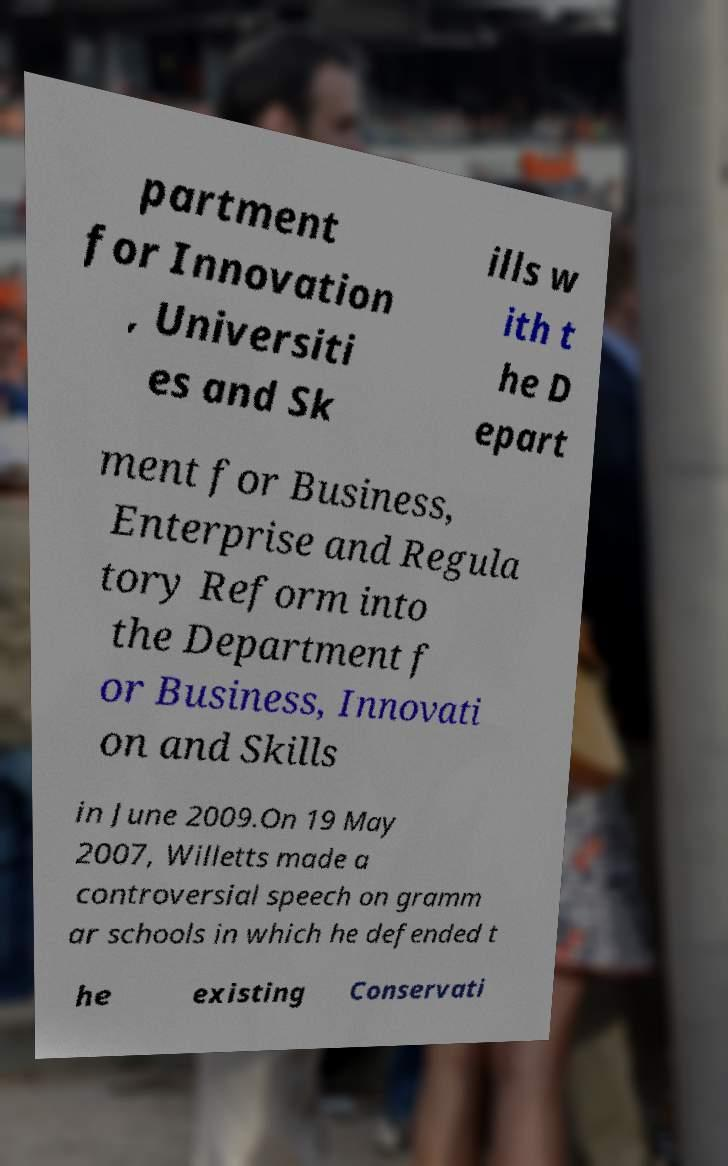Can you accurately transcribe the text from the provided image for me? partment for Innovation , Universiti es and Sk ills w ith t he D epart ment for Business, Enterprise and Regula tory Reform into the Department f or Business, Innovati on and Skills in June 2009.On 19 May 2007, Willetts made a controversial speech on gramm ar schools in which he defended t he existing Conservati 